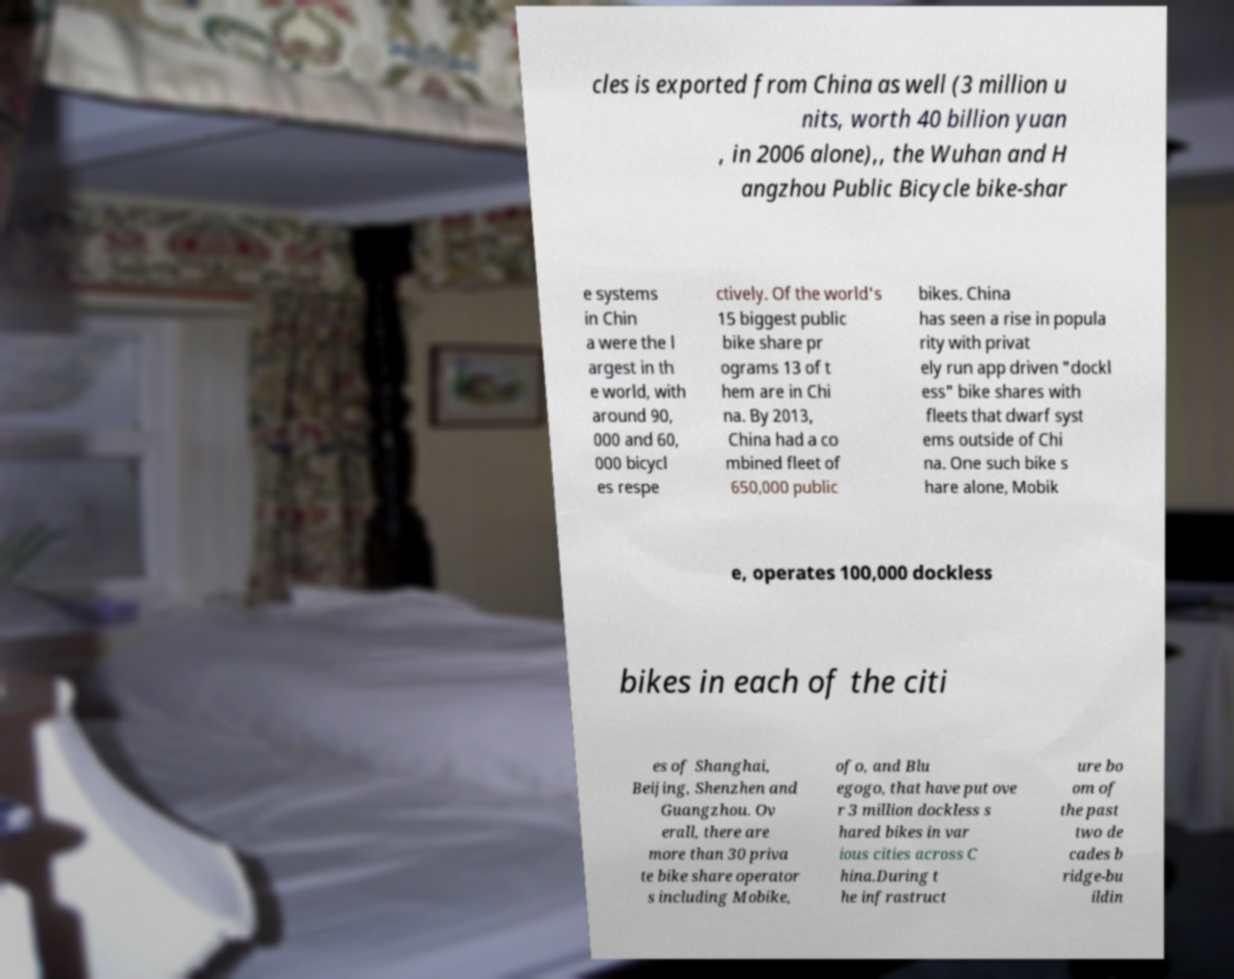Could you extract and type out the text from this image? cles is exported from China as well (3 million u nits, worth 40 billion yuan , in 2006 alone),, the Wuhan and H angzhou Public Bicycle bike-shar e systems in Chin a were the l argest in th e world, with around 90, 000 and 60, 000 bicycl es respe ctively. Of the world's 15 biggest public bike share pr ograms 13 of t hem are in Chi na. By 2013, China had a co mbined fleet of 650,000 public bikes. China has seen a rise in popula rity with privat ely run app driven "dockl ess" bike shares with fleets that dwarf syst ems outside of Chi na. One such bike s hare alone, Mobik e, operates 100,000 dockless bikes in each of the citi es of Shanghai, Beijing, Shenzhen and Guangzhou. Ov erall, there are more than 30 priva te bike share operator s including Mobike, ofo, and Blu egogo, that have put ove r 3 million dockless s hared bikes in var ious cities across C hina.During t he infrastruct ure bo om of the past two de cades b ridge-bu ildin 